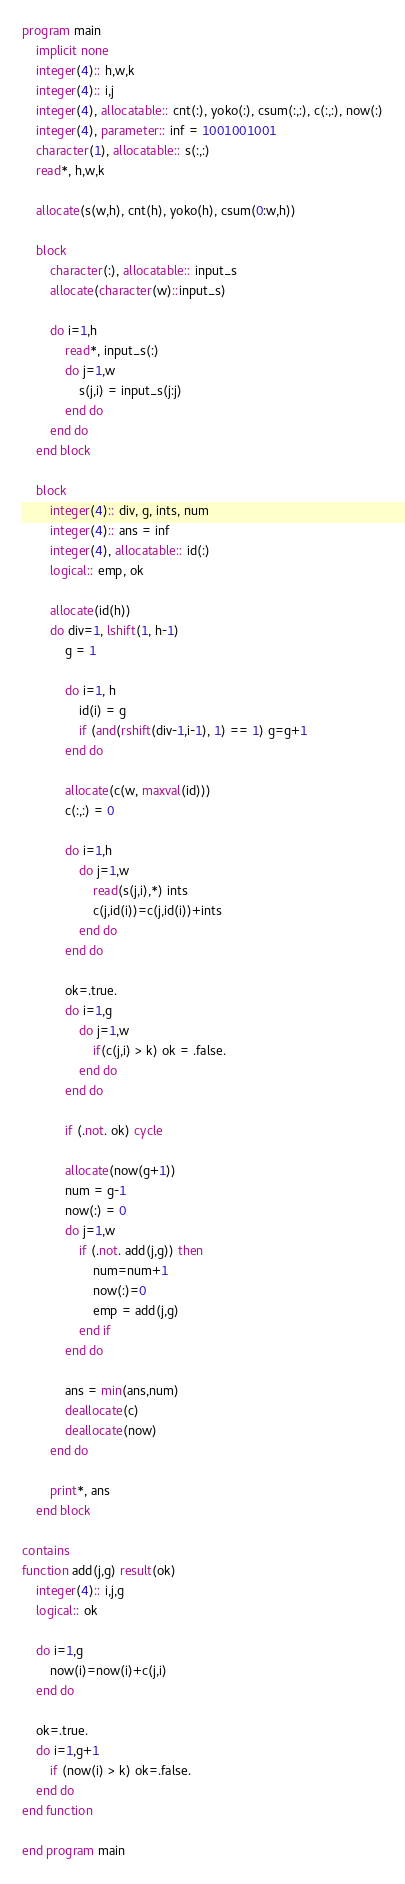<code> <loc_0><loc_0><loc_500><loc_500><_FORTRAN_>program main
    implicit none
    integer(4):: h,w,k
    integer(4):: i,j
    integer(4), allocatable:: cnt(:), yoko(:), csum(:,:), c(:,:), now(:)
    integer(4), parameter:: inf = 1001001001
    character(1), allocatable:: s(:,:)
    read*, h,w,k
 
    allocate(s(w,h), cnt(h), yoko(h), csum(0:w,h))

    block
        character(:), allocatable:: input_s
        allocate(character(w)::input_s)

        do i=1,h
            read*, input_s(:)
            do j=1,w
                s(j,i) = input_s(j:j)
            end do
        end do
    end block

    block
        integer(4):: div, g, ints, num
        integer(4):: ans = inf
        integer(4), allocatable:: id(:)
        logical:: emp, ok

        allocate(id(h))
        do div=1, lshift(1, h-1)
            g = 1

            do i=1, h
                id(i) = g
                if (and(rshift(div-1,i-1), 1) == 1) g=g+1
            end do

            allocate(c(w, maxval(id)))
            c(:,:) = 0

            do i=1,h
                do j=1,w
                    read(s(j,i),*) ints
                    c(j,id(i))=c(j,id(i))+ints
                end do 
            end do

            ok=.true.
            do i=1,g
                do j=1,w
                    if(c(j,i) > k) ok = .false.
                end do
            end do

            if (.not. ok) cycle

            allocate(now(g+1))
            num = g-1
            now(:) = 0
            do j=1,w
                if (.not. add(j,g)) then
                    num=num+1
                    now(:)=0
                    emp = add(j,g)
                end if
            end do 

            ans = min(ans,num)
            deallocate(c)
            deallocate(now)
        end do

        print*, ans
    end block

contains
function add(j,g) result(ok)
    integer(4):: i,j,g
    logical:: ok

    do i=1,g
        now(i)=now(i)+c(j,i)
    end do

    ok=.true.
    do i=1,g+1
        if (now(i) > k) ok=.false.
    end do
end function

end program main</code> 